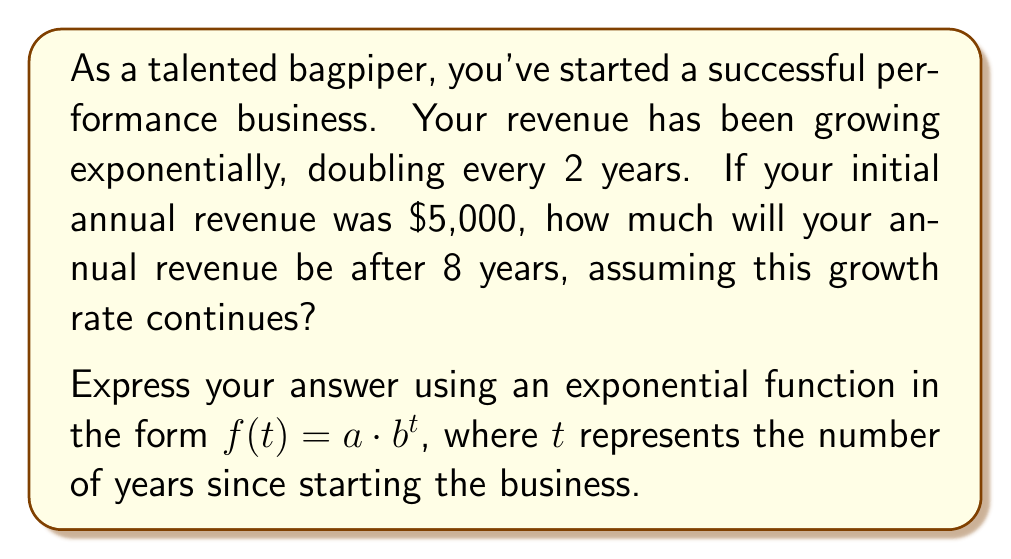Teach me how to tackle this problem. Let's solve this step-by-step:

1) The general form of an exponential function is:
   $f(t) = a \cdot b^t$

   Where:
   $a$ is the initial value
   $b$ is the growth factor
   $t$ is the time

2) We know:
   - Initial revenue ($a$) = $5,000
   - Revenue doubles every 2 years
   - We want to find the revenue after 8 years

3) To find $b$, we need to determine the growth factor for 1 year:
   If revenue doubles every 2 years, then for 1 year:
   $b^2 = 2$
   $b = \sqrt{2} \approx 1.4142$

4) Now we can write our function:
   $f(t) = 5000 \cdot (1.4142)^t$

5) To find the revenue after 8 years, we substitute $t = 8$:
   $f(8) = 5000 \cdot (1.4142)^8$

6) Calculate:
   $f(8) = 5000 \cdot 16 = 80,000$

Therefore, after 8 years, the annual revenue will be $80,000.
Answer: $f(t) = 5000 \cdot (1.4142)^t$ 